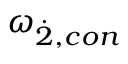Convert formula to latex. <formula><loc_0><loc_0><loc_500><loc_500>{ \omega } _ { \dot { 2 } , c o n }</formula> 